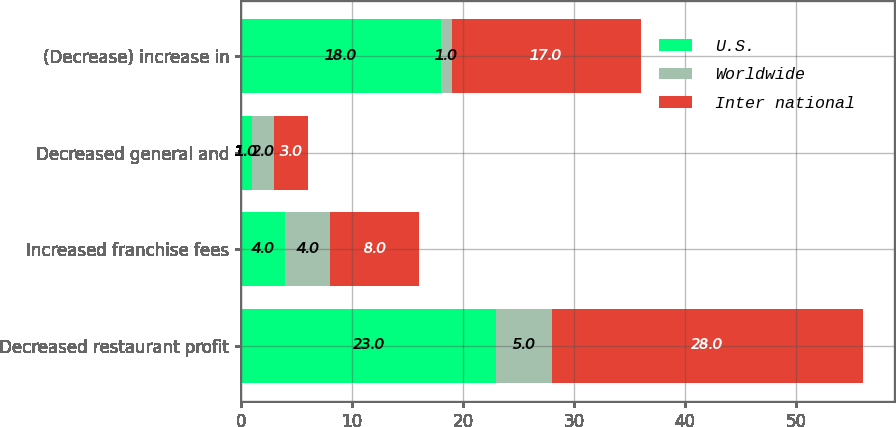Convert chart to OTSL. <chart><loc_0><loc_0><loc_500><loc_500><stacked_bar_chart><ecel><fcel>Decreased restaurant profit<fcel>Increased franchise fees<fcel>Decreased general and<fcel>(Decrease) increase in<nl><fcel>U.S.<fcel>23<fcel>4<fcel>1<fcel>18<nl><fcel>Worldwide<fcel>5<fcel>4<fcel>2<fcel>1<nl><fcel>Inter national<fcel>28<fcel>8<fcel>3<fcel>17<nl></chart> 